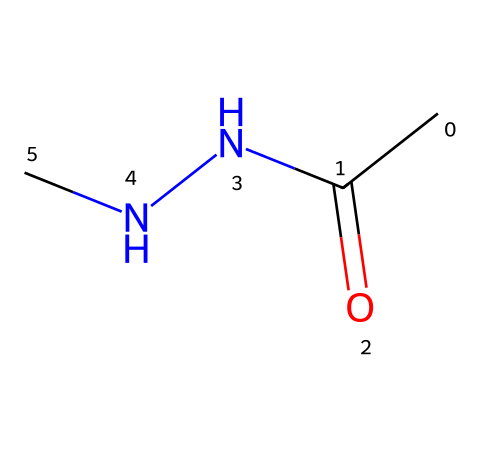What is the molecular formula of acetylhydrazine? By examining the SMILES representation, CC(=O)NNC, we can identify the atoms present. The carbon (C) appears two times, oxygen (O) appears once, and nitrogen (N) appears two times, leading us to calculate the counts: C2, H6, N2, O1. Thus, the molecular formula is C2H6N2O.
Answer: C2H6N2O How many nitrogen atoms are in acetylhydrazine? In the SMILES notation, two nitrogen (N) atoms are indicated, found in the segment “NNC”. Counting the nitrogen atoms provides the total.
Answer: 2 What type of functional group is present in acetylhydrazine? The SMILES structure indicates the presence of a carbonyl group (C=O) attached to a nitrogen atom, signifying that acetylhydrazine contains an amide functional group, specifically as it is linked to hydrazine.
Answer: amide Can acetylhydrazine act as a hydrazine derivative? Both the presence of nitrogen atoms in a hydrazine configuration (N-N) and the inclusion of an acyl group (from the carbonyl) confirm acetylhydrazine's classification as a hydrazine derivative.
Answer: yes What hybridization state do the nitrogen atoms exhibit in acetylhydrazine? By analyzing the structure, we see that one nitrogen atom is part of a single bond with another nitrogen, indicating sp3 hybridization. The other nitrogen is bonded to both the carbonyl and an amine, suggesting it is also sp2 hybridized due to the presence of one double bond, resulting in both nitrogens having different hybridization states.
Answer: sp2 and sp3 How many carbon-to-nitrogen bonds are in acetylhydrazine? The depiction shows two bonds between carbon (from acetyl) and nitrogen (from hydrazine), identified from the carbon atom bonded to nitrogen, and the nitrogen bonds with another nitrogen, confirming a total of two carbon-to-nitrogen bonds.
Answer: 2 